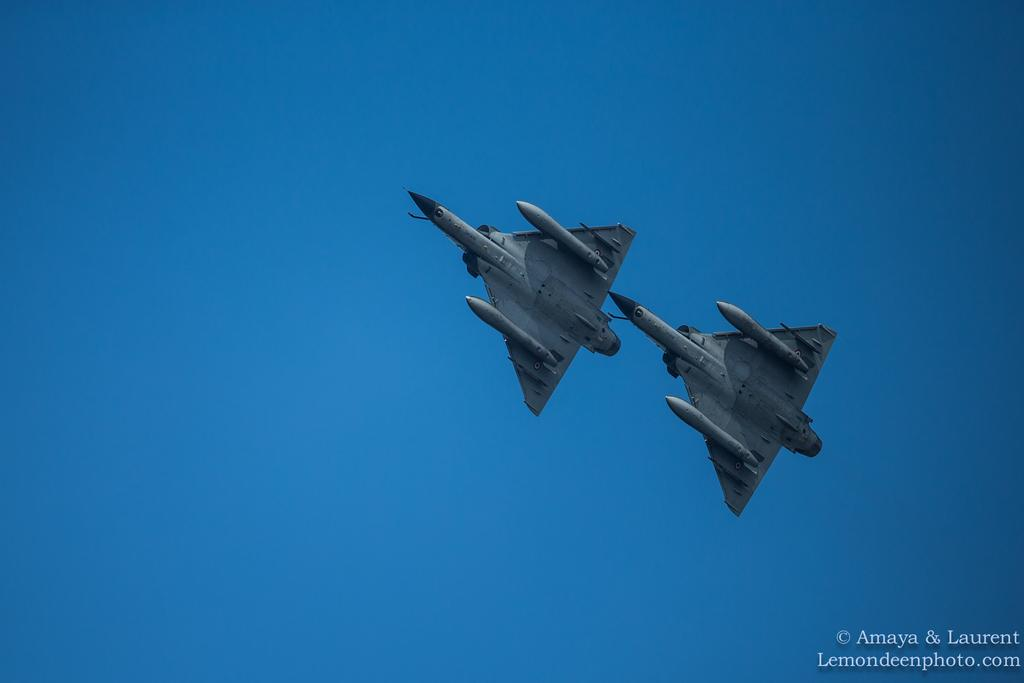<image>
Render a clear and concise summary of the photo. the word Amaya is in the corner with two jets flying 